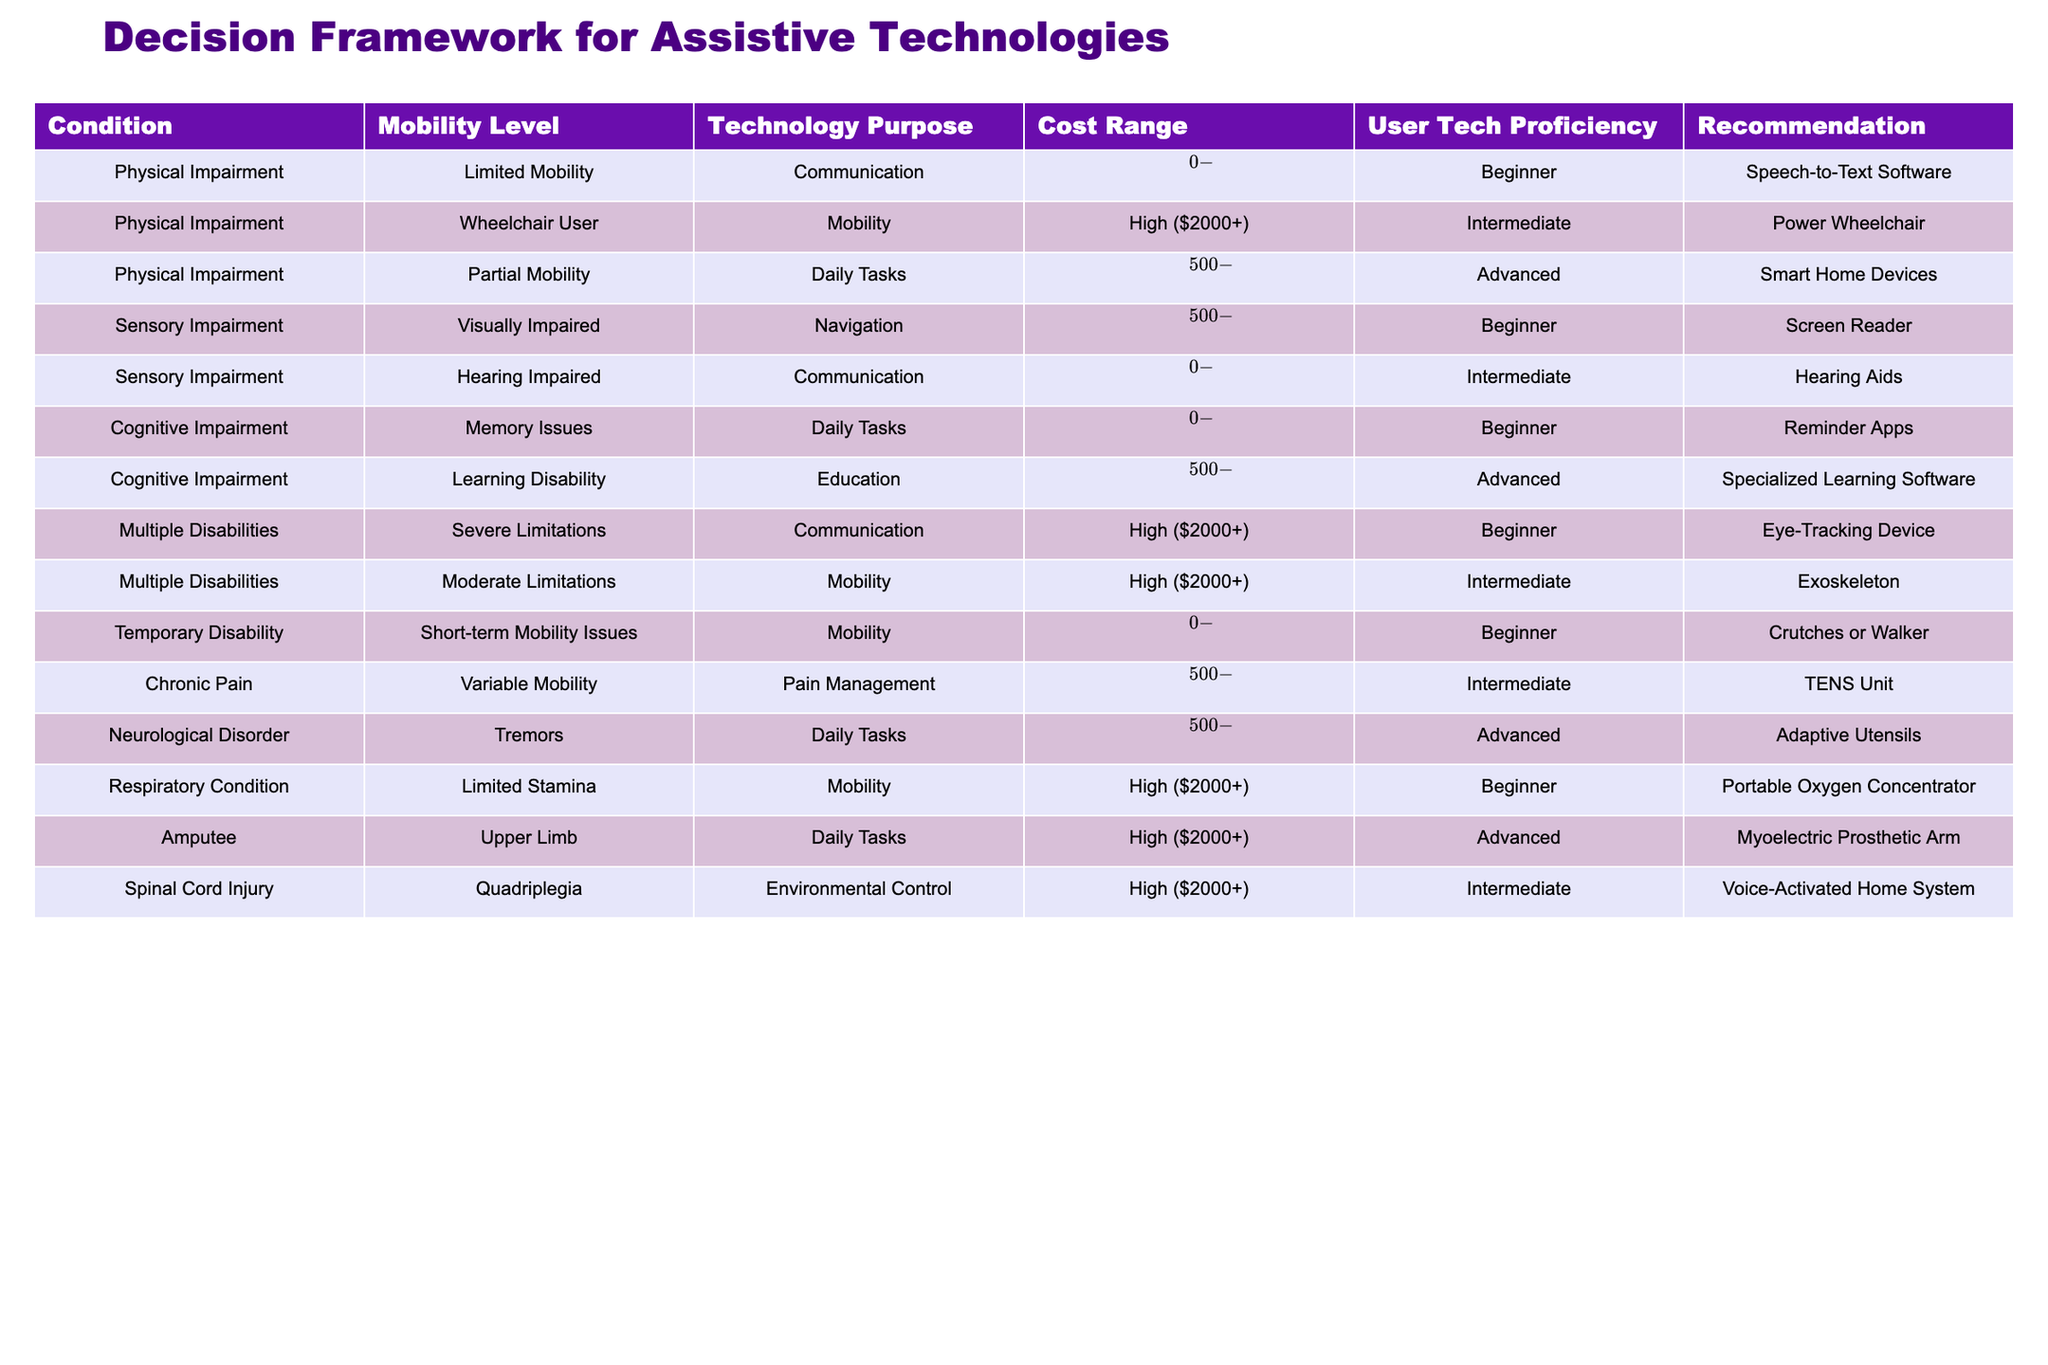What assistive technology is recommended for someone with partial mobility? The table lists "Smart Home Devices" as the recommended technology for individuals with partial mobility.
Answer: Smart Home Devices Which assistive technology for communication has the lowest cost range? The table shows that "Speech-to-Text Software" and "Hearing Aids" both fall within the low cost range of $0-$500 for communication purposes, but "Speech-to-Text Software" is specifically for physical impairment.
Answer: Speech-to-Text Software True or False: A power wheelchair is recommended for users with limited mobility. The table indicates that a power wheelchair is recommended for wheelchair users, not specifically for individuals with limited mobility. Thus, the statement is false.
Answer: False What is the combined cost range for assistive technologies recommended for cognitive impairments? The table lists two assistive technologies for cognitive impairments: "Reminder Apps" (Low $0-$500) and "Specialized Learning Software" (Medium $500-$2000). The combined cost range is Low and Medium, equating to $0 to $2000.
Answer: $0-$2000 Which type of assistive technology serves multiple disabilities and what is its user tech proficiency level? The table shows that "Eye-Tracking Device" is recommended for individuals with severe limitations under multiple disabilities, and the user tech proficiency level is Beginner.
Answer: Eye-Tracking Device, Beginner What is the average cost range of mobility assistive technologies listed in the table? The table highlights three mobility assistive technologies: "Power Wheelchair" (High $2000+), "Exoskeleton" (High $2000+), and "Portable Oxygen Concentrator" (High $2000+). Since they all fall under the high cost category, the average cost can be viewed as high, which generally means above $2000.
Answer: High ($2000+) Is there a communication technology recommended for users with neurological disorders? The table indicates that there is no communication technology specifically listed for neurological disorders. Hence, the answer is no.
Answer: No Which assistive technology for mobility is suitable for someone with a respiratory condition? According to the table, a "Portable Oxygen Concentrator" is recommended for individuals with a respiratory condition and limited stamina.
Answer: Portable Oxygen Concentrator 